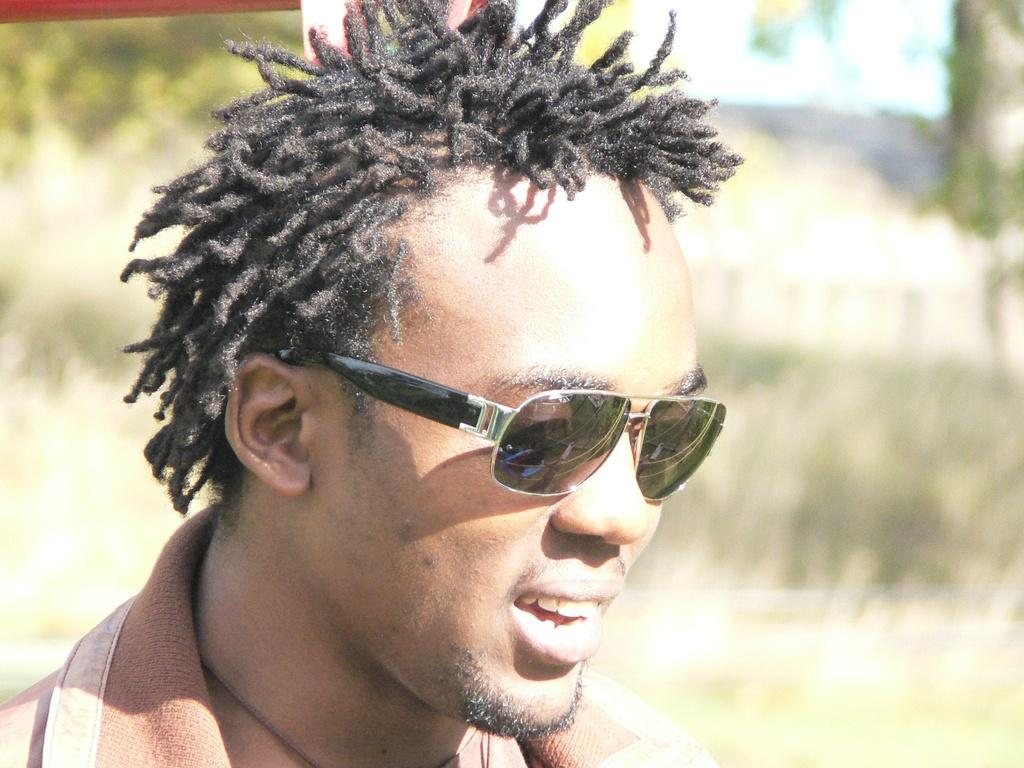Who is present in the image? There is a man in the image. What is the man wearing? The man is wearing clothes and goggles. What is the man's facial expression? The man is smiling. Can you describe the background of the image? The background of the image is blurred. What type of crown is the man wearing in the image? There is no crown present in the image; the man is wearing goggles instead. How many clovers can be seen in the image? There are no clovers present in the image. 